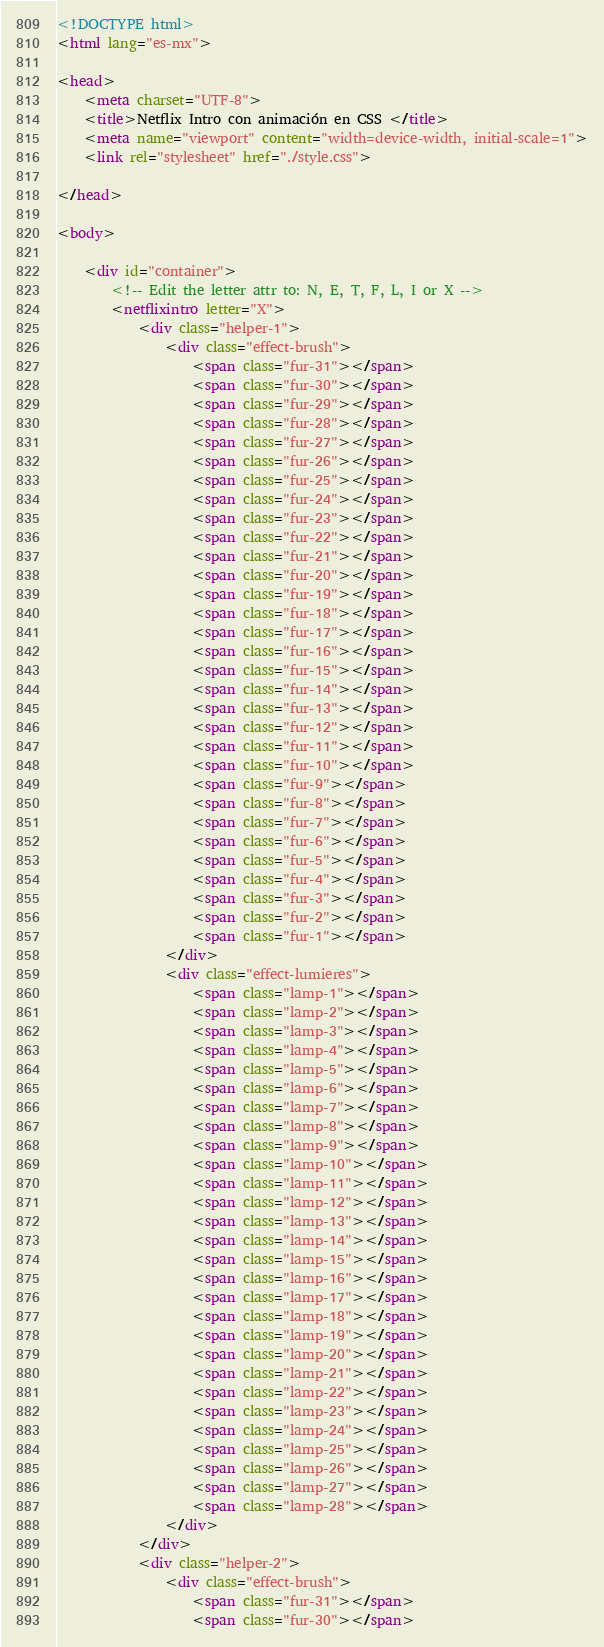<code> <loc_0><loc_0><loc_500><loc_500><_HTML_><!DOCTYPE html>
<html lang="es-mx">

<head>
    <meta charset="UTF-8">
    <title>Netflix Intro con animación en CSS </title>
    <meta name="viewport" content="width=device-width, initial-scale=1">
    <link rel="stylesheet" href="./style.css">

</head>

<body>

    <div id="container">
        <!-- Edit the letter attr to: N, E, T, F, L, I or X -->
        <netflixintro letter="X">
            <div class="helper-1">
                <div class="effect-brush">
                    <span class="fur-31"></span>
                    <span class="fur-30"></span>
                    <span class="fur-29"></span>
                    <span class="fur-28"></span>
                    <span class="fur-27"></span>
                    <span class="fur-26"></span>
                    <span class="fur-25"></span>
                    <span class="fur-24"></span>
                    <span class="fur-23"></span>
                    <span class="fur-22"></span>
                    <span class="fur-21"></span>
                    <span class="fur-20"></span>
                    <span class="fur-19"></span>
                    <span class="fur-18"></span>
                    <span class="fur-17"></span>
                    <span class="fur-16"></span>
                    <span class="fur-15"></span>
                    <span class="fur-14"></span>
                    <span class="fur-13"></span>
                    <span class="fur-12"></span>
                    <span class="fur-11"></span>
                    <span class="fur-10"></span>
                    <span class="fur-9"></span>
                    <span class="fur-8"></span>
                    <span class="fur-7"></span>
                    <span class="fur-6"></span>
                    <span class="fur-5"></span>
                    <span class="fur-4"></span>
                    <span class="fur-3"></span>
                    <span class="fur-2"></span>
                    <span class="fur-1"></span>
                </div>
                <div class="effect-lumieres">
                    <span class="lamp-1"></span>
                    <span class="lamp-2"></span>
                    <span class="lamp-3"></span>
                    <span class="lamp-4"></span>
                    <span class="lamp-5"></span>
                    <span class="lamp-6"></span>
                    <span class="lamp-7"></span>
                    <span class="lamp-8"></span>
                    <span class="lamp-9"></span>
                    <span class="lamp-10"></span>
                    <span class="lamp-11"></span>
                    <span class="lamp-12"></span>
                    <span class="lamp-13"></span>
                    <span class="lamp-14"></span>
                    <span class="lamp-15"></span>
                    <span class="lamp-16"></span>
                    <span class="lamp-17"></span>
                    <span class="lamp-18"></span>
                    <span class="lamp-19"></span>
                    <span class="lamp-20"></span>
                    <span class="lamp-21"></span>
                    <span class="lamp-22"></span>
                    <span class="lamp-23"></span>
                    <span class="lamp-24"></span>
                    <span class="lamp-25"></span>
                    <span class="lamp-26"></span>
                    <span class="lamp-27"></span>
                    <span class="lamp-28"></span>
                </div>
            </div>
            <div class="helper-2">
                <div class="effect-brush">
                    <span class="fur-31"></span>
                    <span class="fur-30"></span></code> 